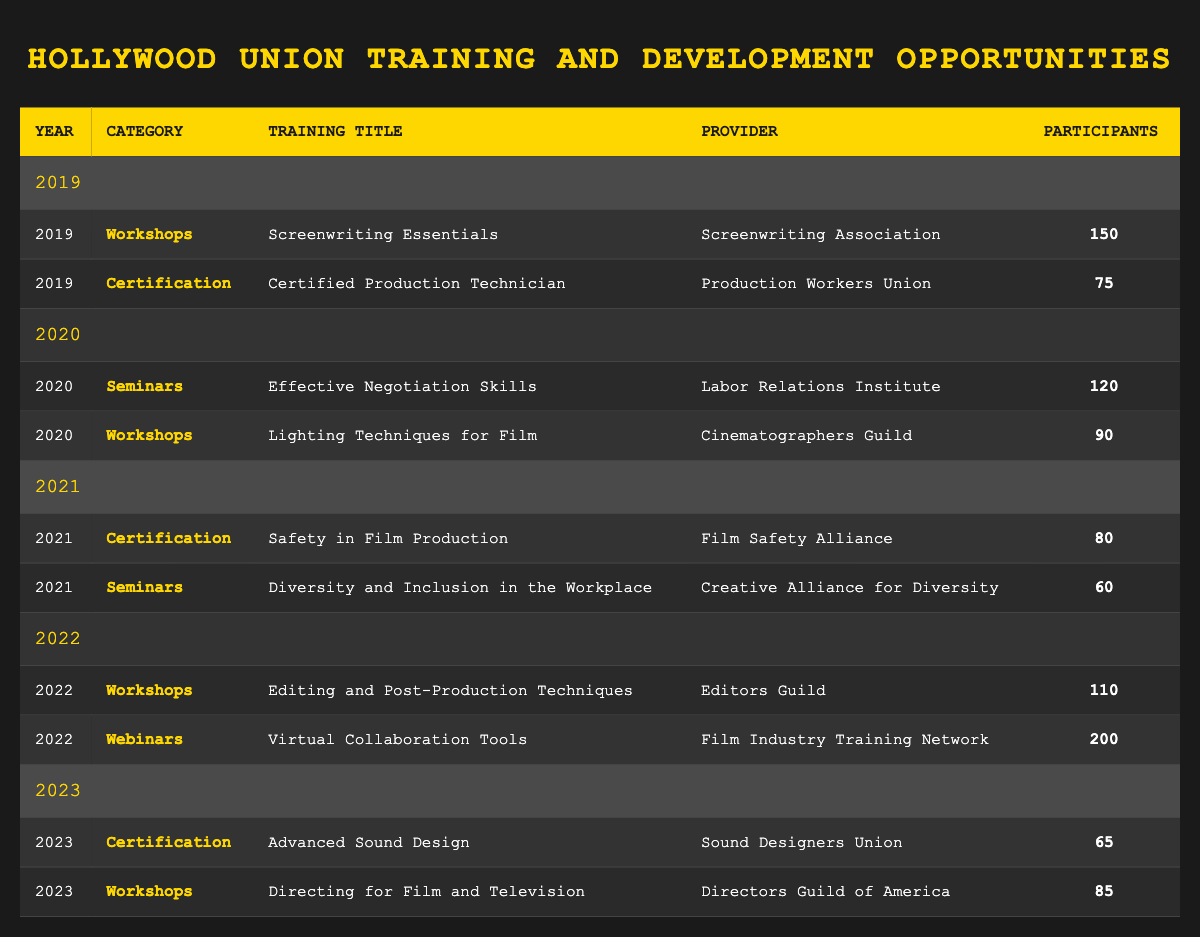What training opportunity had the highest number of participants in 2022? In 2022, the training titled "Virtual Collaboration Tools" had the highest number of participants with 200.
Answer: Virtual Collaboration Tools How many workshops were conducted in 2020? There were two workshops conducted in 2020: "Effective Negotiation Skills" with 120 participants and "Lighting Techniques for Film" with 90 participants.
Answer: 2 Which training category had the least number of participants in 2021? In 2021, the category with the least number of participants was "Seminars", specifically the training "Diversity and Inclusion in the Workplace" with 60 participants.
Answer: Seminars What was the total number of participants across all training opportunities in 2019? In 2019, the total number of participants was calculated by adding the participants from each training: 150 (Workshops) + 75 (Certification) = 225.
Answer: 225 Is there any training offered in 2023 that had more participants than any in 2019? Yes, in 2023, the training "Directing for Film and Television" had 85 participants, which is more than the 75 participants of "Certified Production Technician" in 2019.
Answer: Yes What is the average number of participants in the "Certification" category across all years? For the "Certification" category, there were 75 participants in 2019, 80 in 2021, and 65 in 2023. To find the average, sum them up: 75 + 80 + 65 = 220, then divide by 3, resulting in an average of 220/3 ≈ 73.33.
Answer: 73.33 How many participants attended workshops in total over the years? Adding the participants in the workshop category from each year gives: 150 (2019) + 90 (2020) + 110 (2022) + 85 (2023) = 435.
Answer: 435 In which year was the "Safety in Film Production" training offered? The "Safety in Film Production" training was offered in 2021, as indicated in the table.
Answer: 2021 Did the number of participants in webinars exceed those in workshops in 2022? Yes, in 2022, the webinar "Virtual Collaboration Tools" had 200 participants, which exceeds the workshop "Editing and Post-Production Techniques" with 110 participants.
Answer: Yes 